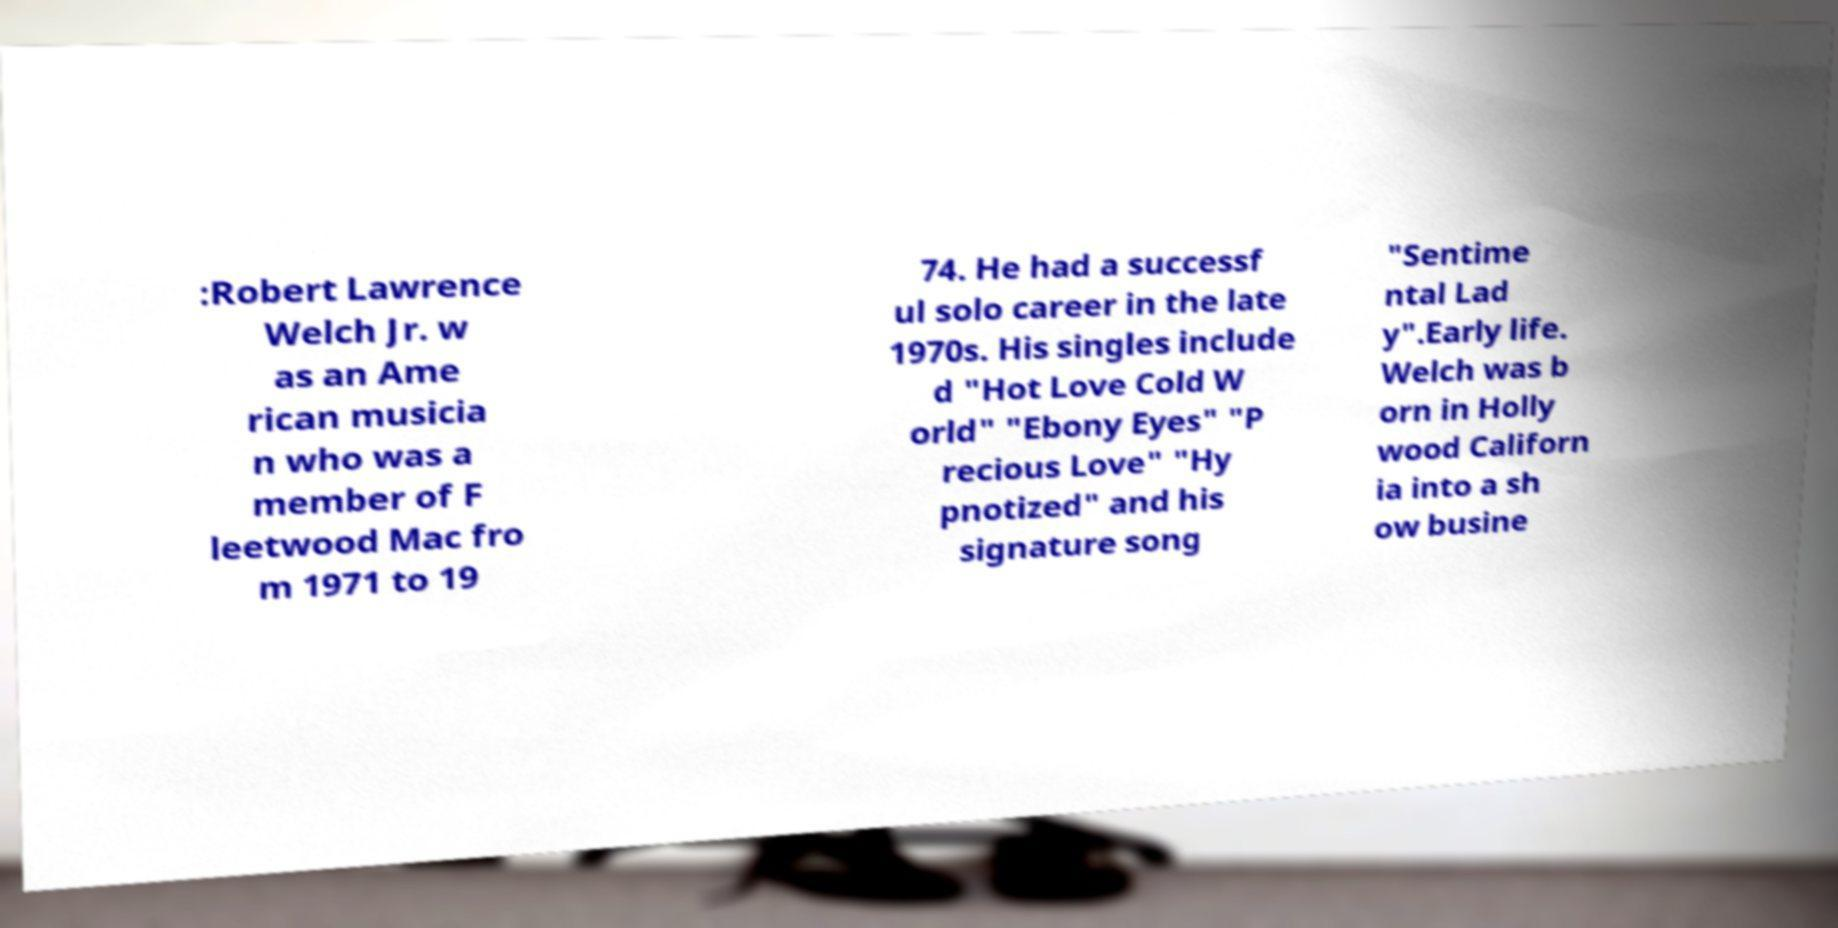Could you extract and type out the text from this image? :Robert Lawrence Welch Jr. w as an Ame rican musicia n who was a member of F leetwood Mac fro m 1971 to 19 74. He had a successf ul solo career in the late 1970s. His singles include d "Hot Love Cold W orld" "Ebony Eyes" "P recious Love" "Hy pnotized" and his signature song "Sentime ntal Lad y".Early life. Welch was b orn in Holly wood Californ ia into a sh ow busine 